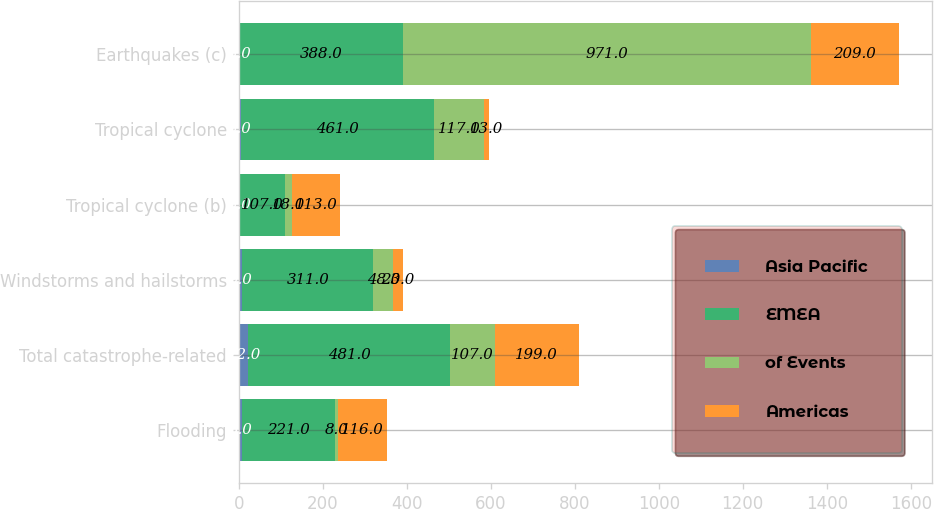<chart> <loc_0><loc_0><loc_500><loc_500><stacked_bar_chart><ecel><fcel>Flooding<fcel>Total catastrophe-related<fcel>Windstorms and hailstorms<fcel>Tropical cyclone (b)<fcel>Tropical cyclone<fcel>Earthquakes (c)<nl><fcel>Asia Pacific<fcel>8<fcel>22<fcel>9<fcel>3<fcel>5<fcel>3<nl><fcel>EMEA<fcel>221<fcel>481<fcel>311<fcel>107<fcel>461<fcel>388<nl><fcel>of Events<fcel>8<fcel>107<fcel>48<fcel>18<fcel>117<fcel>971<nl><fcel>Americas<fcel>116<fcel>199<fcel>23<fcel>113<fcel>13<fcel>209<nl></chart> 